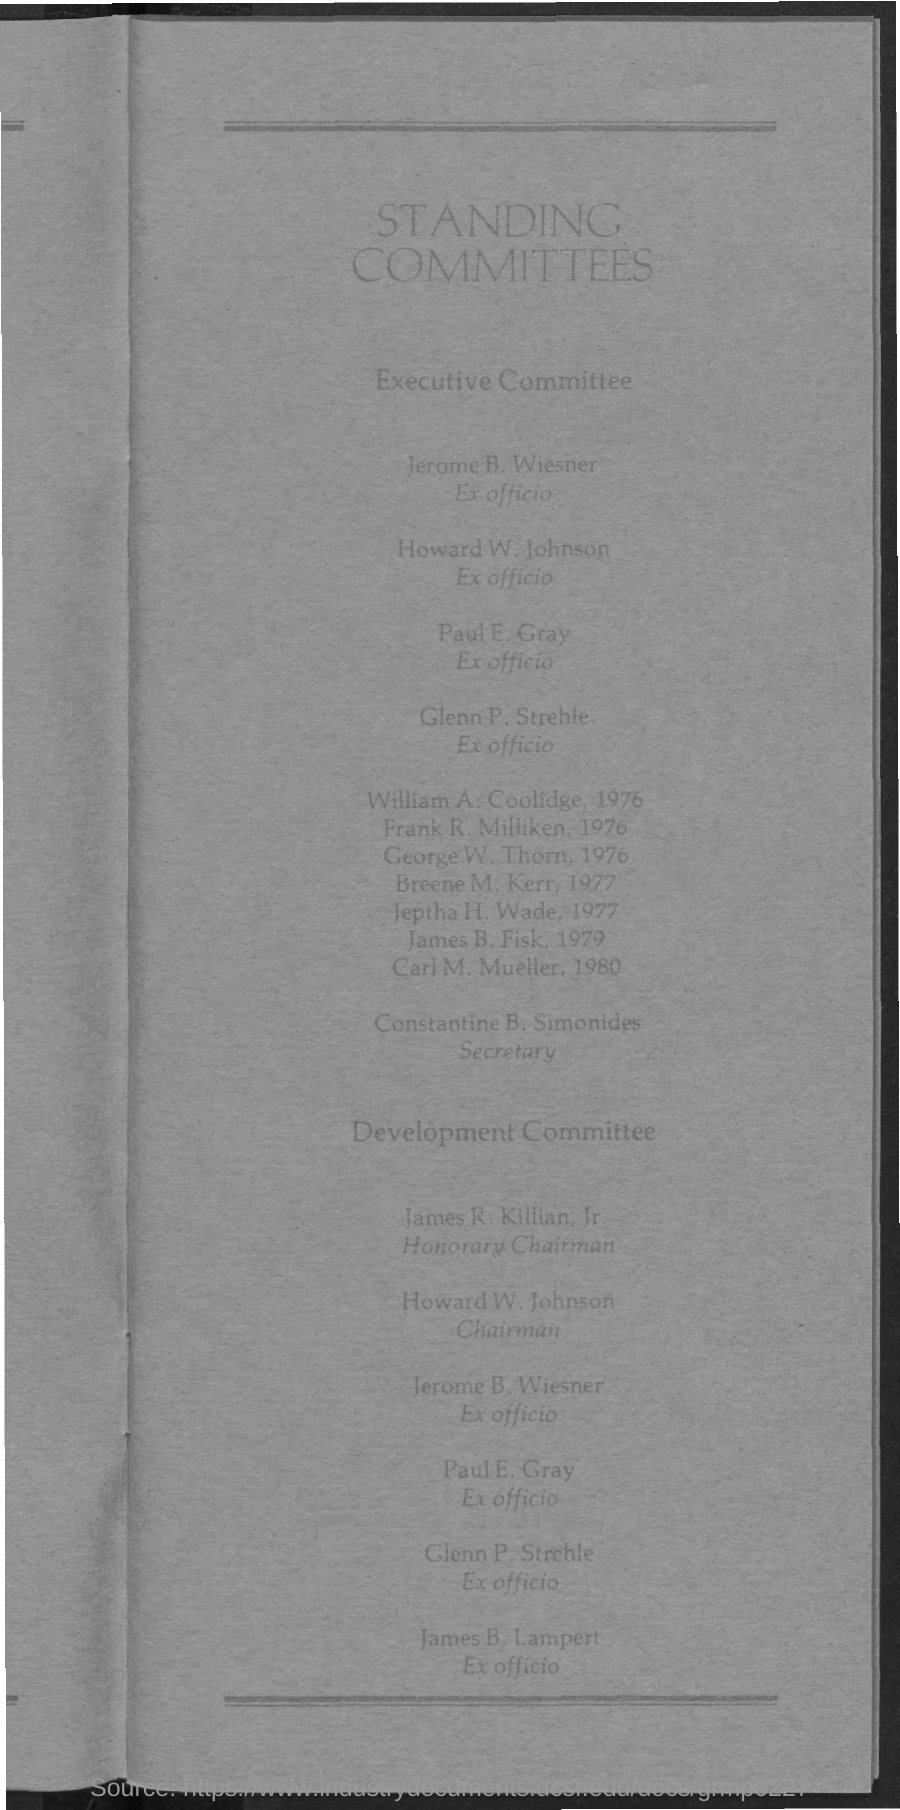What is the designation of Paul E.Gray?
Keep it short and to the point. Ex officio. 